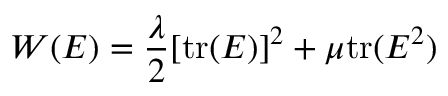<formula> <loc_0><loc_0><loc_500><loc_500>W ( { E } ) = { \frac { \lambda } { 2 } } [ { t r } ( { E } ) ] ^ { 2 } + \mu { t r } ( { E } ^ { 2 } )</formula> 